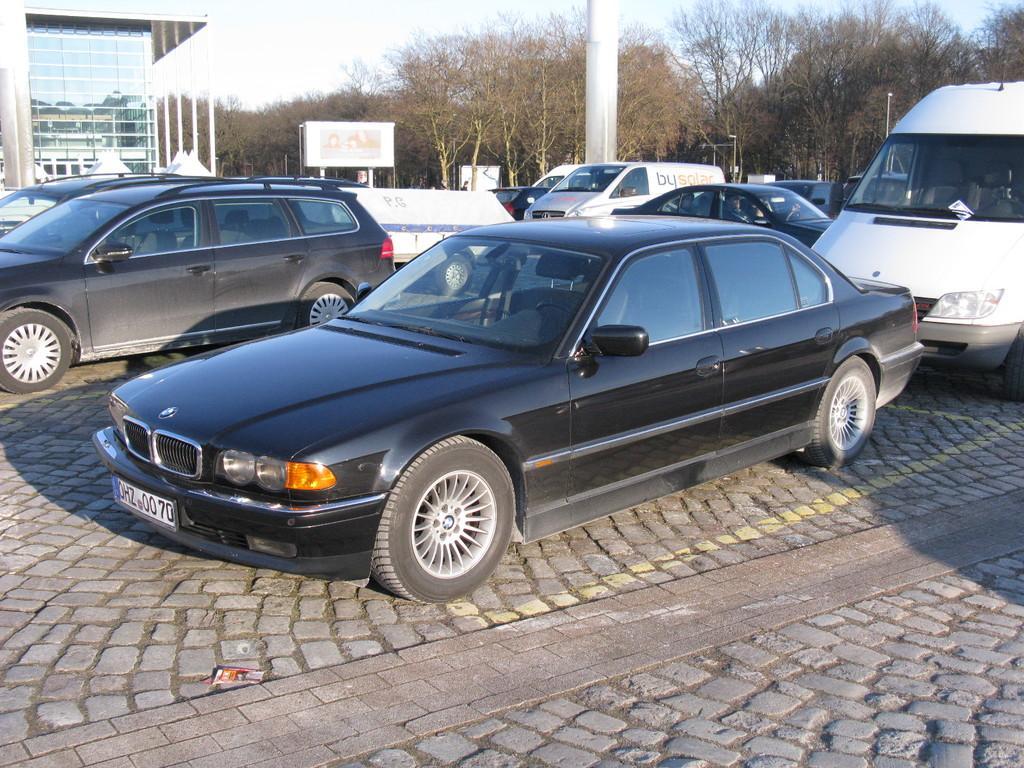In one or two sentences, can you explain what this image depicts? In the foreground I can see fleets of cars and vehicles on the road. In the background I can see trees, buildings, fence and the sky. This image is taken during a day on the road. 